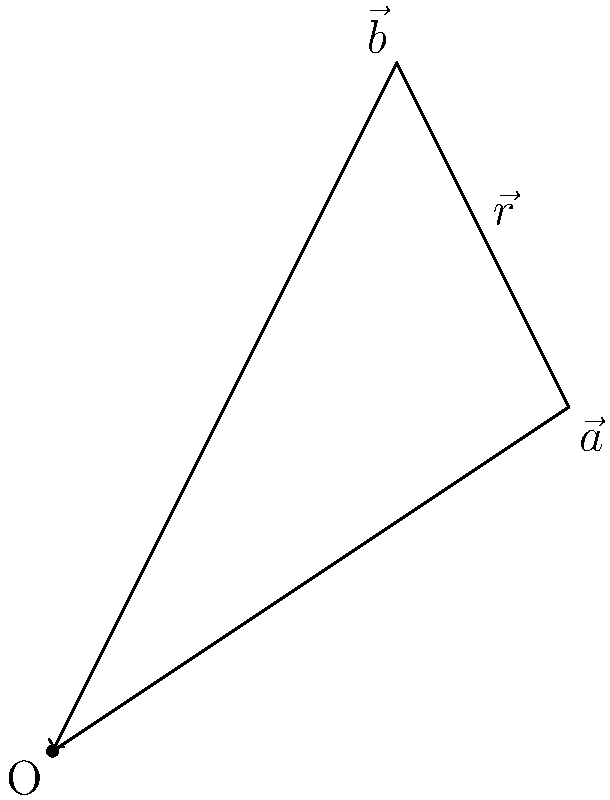In a traditional Kashmiri embroidery pattern, two stitching vectors $\vec{a}$ and $\vec{b}$ are combined to create a resultant vector $\vec{r}$. If $\vec{a} = 3\hat{i} + 2\hat{j}$ and $\vec{b} = 2\hat{i} + 4\hat{j}$, what is the magnitude of the resultant vector $\vec{r}$? To find the magnitude of the resultant vector $\vec{r}$, we need to follow these steps:

1. Add the two vectors $\vec{a}$ and $\vec{b}$ to get $\vec{r}$:
   $\vec{r} = \vec{a} + \vec{b} = (3\hat{i} + 2\hat{j}) + (2\hat{i} + 4\hat{j})$

2. Combine like terms:
   $\vec{r} = (3+2)\hat{i} + (2+4)\hat{j} = 5\hat{i} + 6\hat{j}$

3. Use the Pythagorean theorem to calculate the magnitude of $\vec{r}$:
   $|\vec{r}| = \sqrt{(5)^2 + (6)^2}$

4. Simplify:
   $|\vec{r}| = \sqrt{25 + 36} = \sqrt{61}$

Therefore, the magnitude of the resultant vector $\vec{r}$ is $\sqrt{61}$ units.
Answer: $\sqrt{61}$ units 